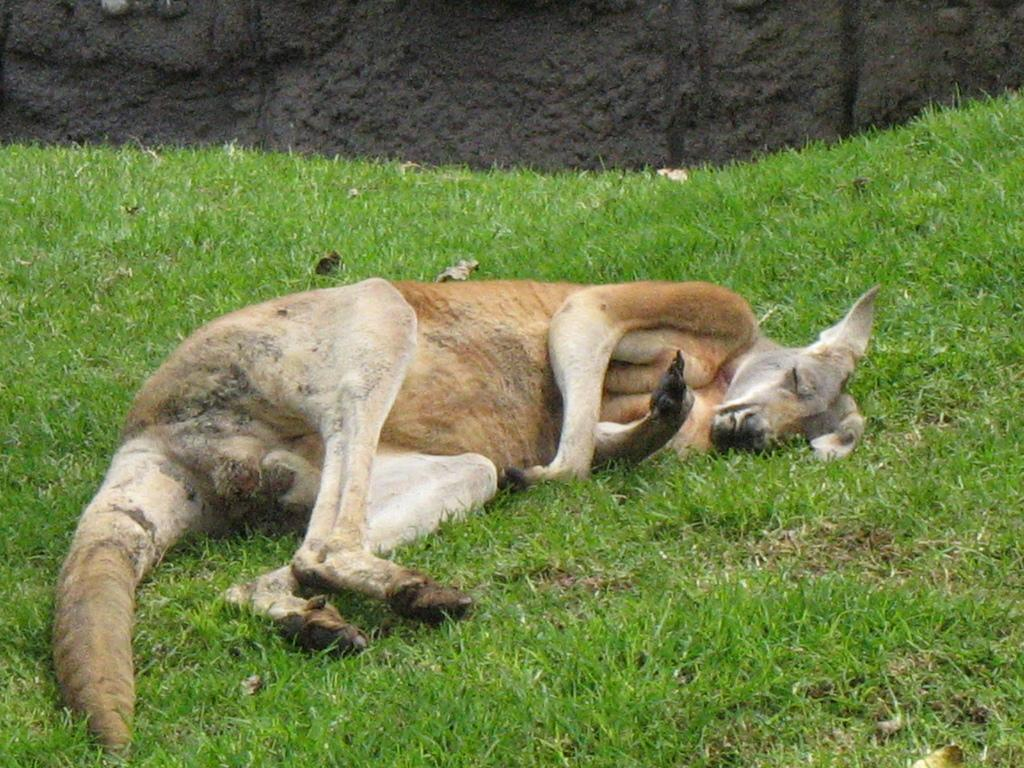What animal can be seen in the image? There is a kangaroo in the image. What is the kangaroo doing in the image? The kangaroo is sleeping on the ground. What type of terrain is visible in the image? The ground is full of grass. What type of vest is the kangaroo wearing in the image? There is no vest present in the image; the kangaroo is not wearing any clothing. 